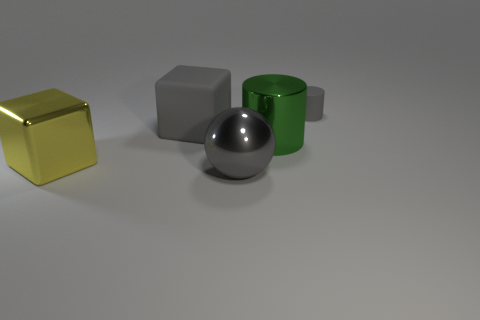How does the lighting in the image affect the appearance of the objects? The lighting creates distinct highlights and shadows on the objects, accentuating their shapes and giving a sense of depth. The reflective surfaces, like that of the metallic sphere, mirror the light differently compared to the matte objects, which absorb more light, resulting in varied appearances. 